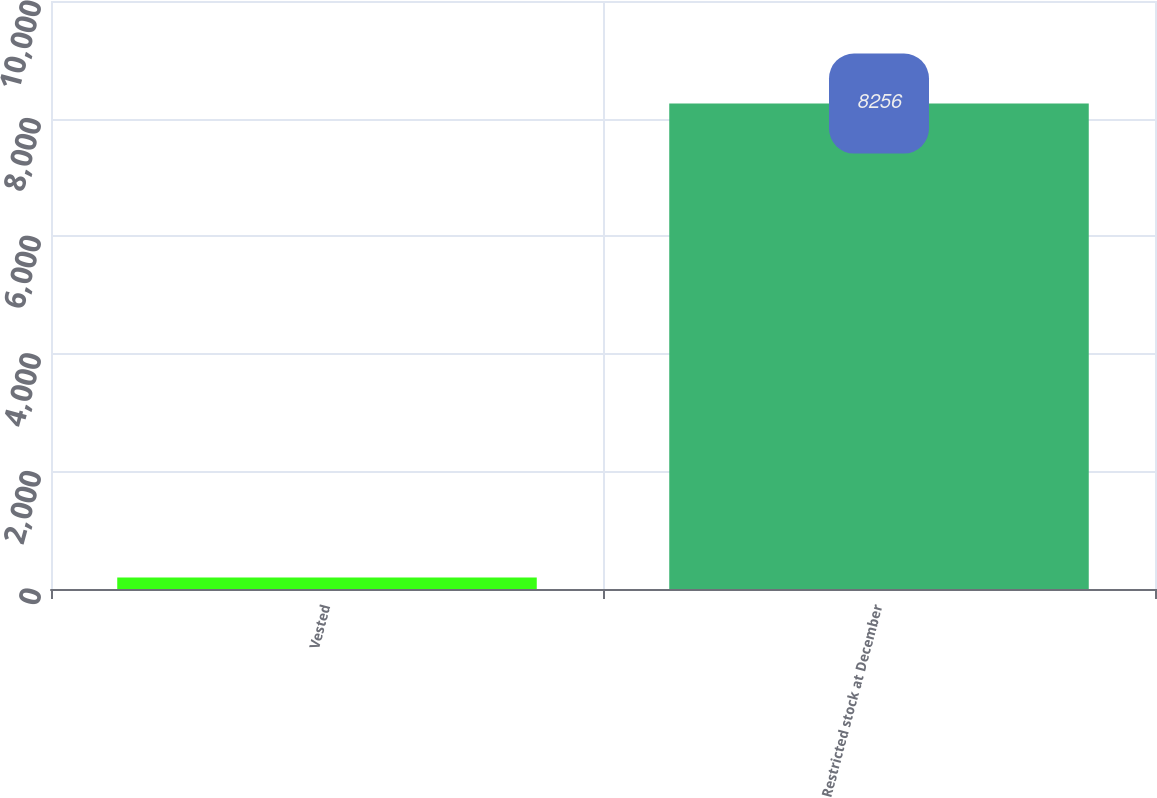Convert chart. <chart><loc_0><loc_0><loc_500><loc_500><bar_chart><fcel>Vested<fcel>Restricted stock at December<nl><fcel>197<fcel>8256<nl></chart> 